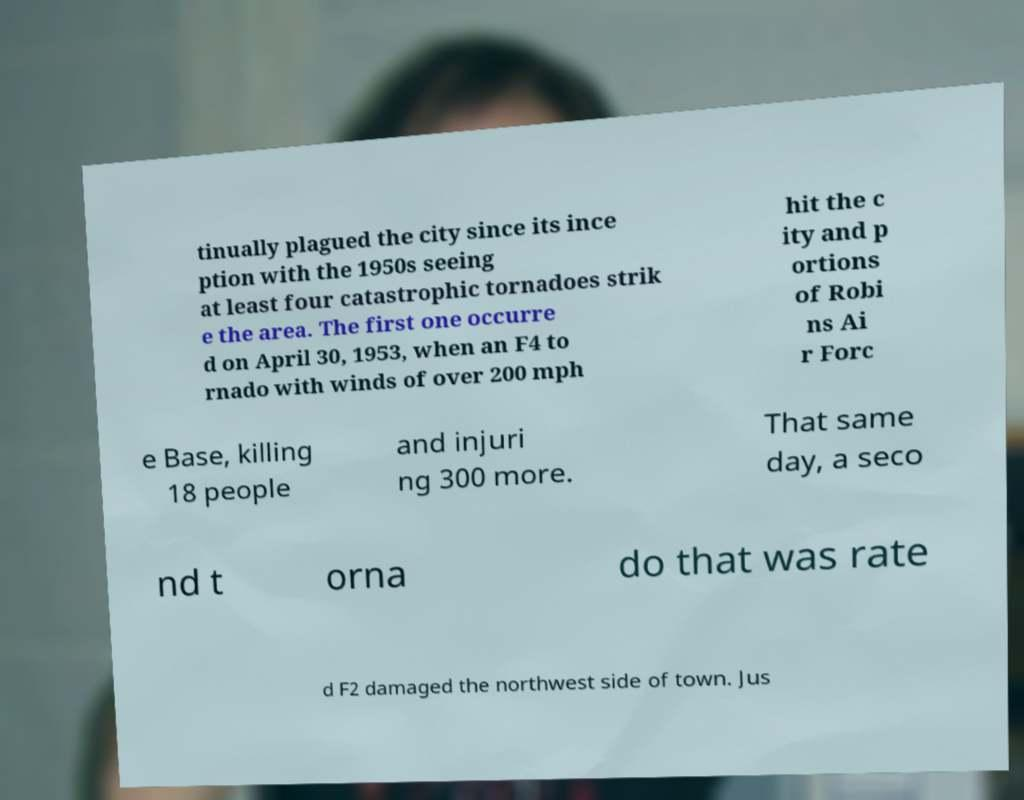Please read and relay the text visible in this image. What does it say? tinually plagued the city since its ince ption with the 1950s seeing at least four catastrophic tornadoes strik e the area. The first one occurre d on April 30, 1953, when an F4 to rnado with winds of over 200 mph hit the c ity and p ortions of Robi ns Ai r Forc e Base, killing 18 people and injuri ng 300 more. That same day, a seco nd t orna do that was rate d F2 damaged the northwest side of town. Jus 